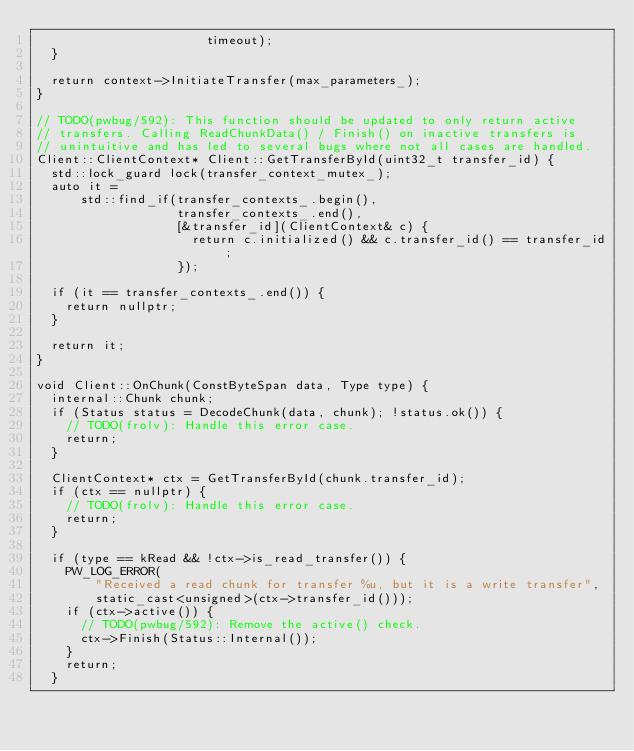<code> <loc_0><loc_0><loc_500><loc_500><_C++_>                       timeout);
  }

  return context->InitiateTransfer(max_parameters_);
}

// TODO(pwbug/592): This function should be updated to only return active
// transfers. Calling ReadChunkData() / Finish() on inactive transfers is
// unintuitive and has led to several bugs where not all cases are handled.
Client::ClientContext* Client::GetTransferById(uint32_t transfer_id) {
  std::lock_guard lock(transfer_context_mutex_);
  auto it =
      std::find_if(transfer_contexts_.begin(),
                   transfer_contexts_.end(),
                   [&transfer_id](ClientContext& c) {
                     return c.initialized() && c.transfer_id() == transfer_id;
                   });

  if (it == transfer_contexts_.end()) {
    return nullptr;
  }

  return it;
}

void Client::OnChunk(ConstByteSpan data, Type type) {
  internal::Chunk chunk;
  if (Status status = DecodeChunk(data, chunk); !status.ok()) {
    // TODO(frolv): Handle this error case.
    return;
  }

  ClientContext* ctx = GetTransferById(chunk.transfer_id);
  if (ctx == nullptr) {
    // TODO(frolv): Handle this error case.
    return;
  }

  if (type == kRead && !ctx->is_read_transfer()) {
    PW_LOG_ERROR(
        "Received a read chunk for transfer %u, but it is a write transfer",
        static_cast<unsigned>(ctx->transfer_id()));
    if (ctx->active()) {
      // TODO(pwbug/592): Remove the active() check.
      ctx->Finish(Status::Internal());
    }
    return;
  }
</code> 